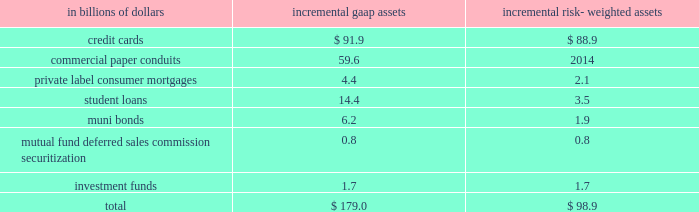Commitments .
For a further description of the loan loss reserve and related accounts , see 201cmanaging global risk 201d and notes 1 and 18 to the consolidated financial statements on pages 51 , 122 and 165 , respectively .
Securitizations the company securitizes a number of different asset classes as a means of strengthening its balance sheet and accessing competitive financing rates in the market .
Under these securitization programs , assets are sold into a trust and used as collateral by the trust to obtain financing .
The cash flows from assets in the trust service the corresponding trust securities .
If the structure of the trust meets certain accounting guidelines , trust assets are treated as sold and are no longer reflected as assets of the company .
If these guidelines are not met , the assets continue to be recorded as the company 2019s assets , with the financing activity recorded as liabilities on citigroup 2019s balance sheet .
Citigroup also assists its clients in securitizing their financial assets and packages and securitizes financial assets purchased in the financial markets .
The company may also provide administrative , asset management , underwriting , liquidity facilities and/or other services to the resulting securitization entities and may continue to service some of these financial assets .
Elimination of qspes and changes in the fin 46 ( r ) consolidation model the fasb has issued an exposure draft of a proposed standard that would eliminate qualifying special purpose entities ( qspes ) from the guidance in fasb statement no .
140 , accounting for transfers and servicing of financial assets and extinguishments of liabilities ( sfas 140 ) .
While the proposed standard has not been finalized , if it is issued in its current form it will have a significant impact on citigroup 2019s consolidated financial statements as the company will lose sales treatment for certain assets previously sold to a qspe , as well as for certain future sales , and for certain transfers of portions of assets that do not meet the proposed definition of 201cparticipating interests . 201d this proposed revision could become effective on january 1 , 2010 .
In connection with the proposed changes to sfas 140 , the fasb has also issued a separate exposure draft of a proposed standard that proposes three key changes to the consolidation model in fasb interpretation no .
46 ( revised december 2003 ) , 201cconsolidation of variable interest entities 201d ( fin 46 ( r ) ) .
First , the revised standard would include former qspes in the scope of fin 46 ( r ) .
In addition , fin 46 ( r ) would be amended to change the method of analyzing which party to a variable interest entity ( vie ) should consolidate the vie ( such consolidating entity is referred to as the 201cprimary beneficiary 201d ) to a qualitative determination of power combined with benefits or losses instead of the current risks and rewards model .
Finally , the proposed standard would require that the analysis of primary beneficiaries be re-evaluated whenever circumstances change .
The existing standard requires reconsideration only when specified reconsideration events occur .
The fasb is currently deliberating these proposed standards , and they are , accordingly , still subject to change .
Since qspes will likely be eliminated from sfas 140 and thus become subject to fin 46 ( r ) consolidation guidance and because the fin 46 ( r ) method of determining which party must consolidate a vie will likely change should this proposed standard become effective , the company expects to consolidate certain of the currently unconsolidated vies and qspes with which citigroup was involved as of december 31 , 2008 .
The company 2019s estimate of the incremental impact of adopting these changes on citigroup 2019s consolidated balance sheets and risk-weighted assets , based on december 31 , 2008 balances , our understanding of the proposed changes to the standards and a proposed january 1 , 2010 effective date , is presented below .
The actual impact of adopting the amended standards as of january 1 , 2010 could materially differ .
The pro forma impact of the proposed changes on gaap assets and risk- weighted assets , assuming application of existing risk-based capital rules , at january 1 , 2010 ( based on the balances at december 31 , 2008 ) would result in the consolidation of incremental assets as follows: .
The table reflects ( i ) the estimated portion of the assets of qspes to which citigroup , acting as principal , has transferred assets and received sales treatment as of december 31 , 2008 ( totaling approximately $ 822.1 billion ) , and ( ii ) the estimated assets of significant unconsolidated vies as of december 31 , 2008 with which citigroup is involved ( totaling approximately $ 288.0 billion ) that would be consolidated under the proposal .
Due to the variety of transaction structures and level of the company 2019s involvement in individual qspes and vies , only a subset of the qspes and vies with which the company is involved are expected to be consolidated under the proposed change .
A complete description of the company 2019s accounting for securitized assets can be found in note 1 to the consolidated financial statements on page 122. .
What percentage of incremental risk-weighted assets are credit cards at january 1 , 2010? 
Computations: (88.9 / 98.9)
Answer: 0.89889. 